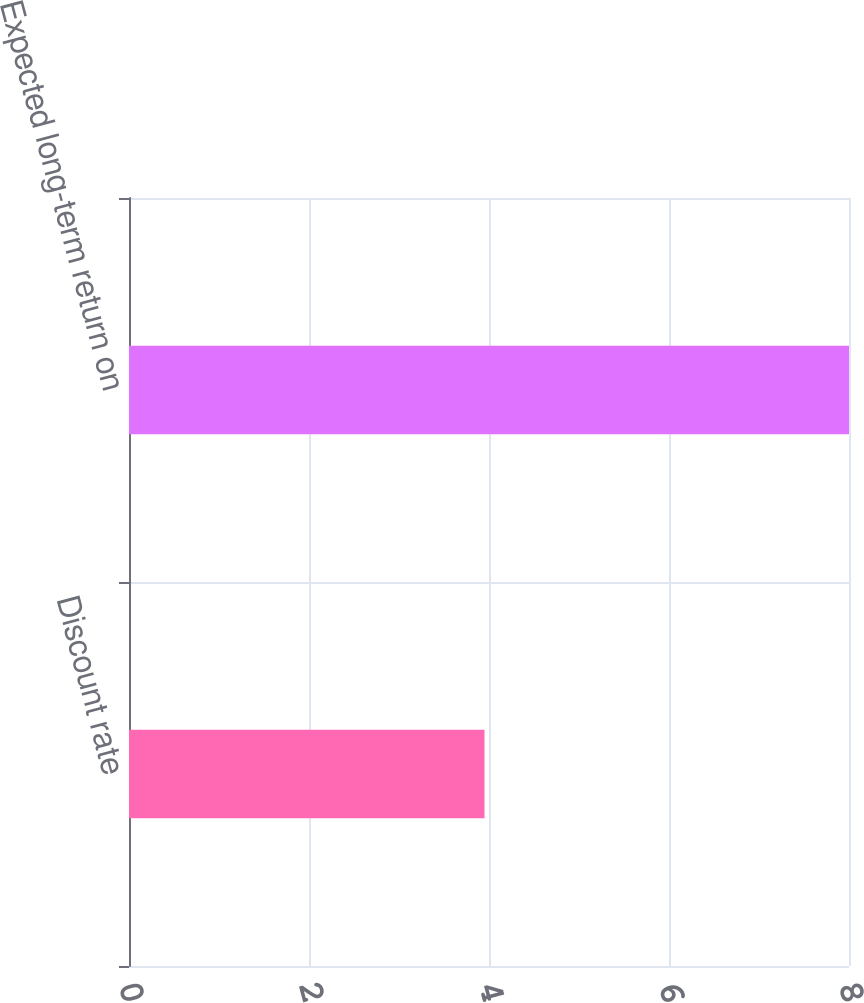<chart> <loc_0><loc_0><loc_500><loc_500><bar_chart><fcel>Discount rate<fcel>Expected long-term return on<nl><fcel>3.95<fcel>8<nl></chart> 